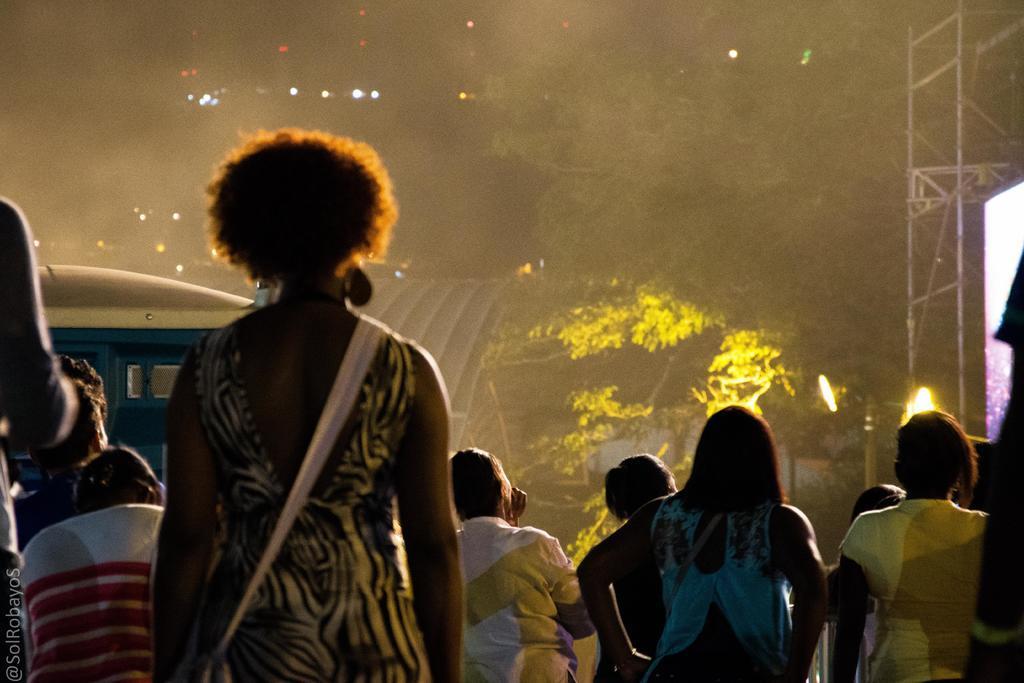Can you describe this image briefly? In this picture we can see a group of people standing and in front of the people, it looks like a vehicle. On the right side of the vehicle there is a tree and it looks like a truss pole. Behind the tree there are lights. 